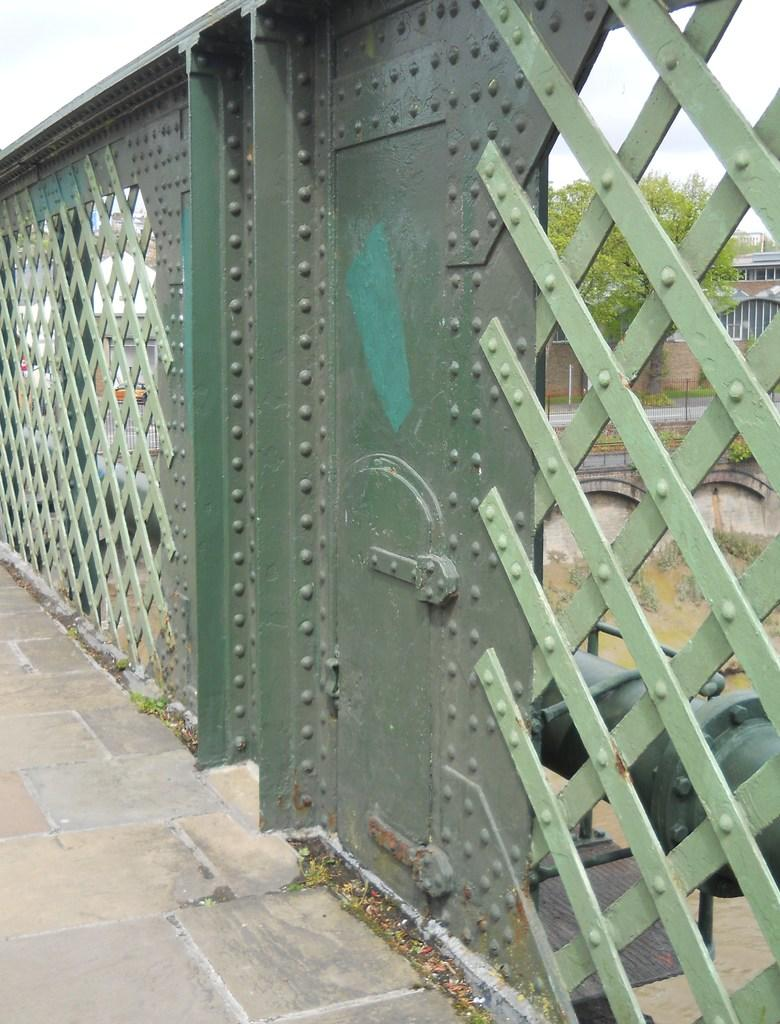What is the main subject in the center of the image? There is a fencing in the center of the image. What type of natural elements can be seen in the image? There are trees in the image. What type of surface is visible at the bottom of the image? There is flooring at the bottom of the image. What route does the ball take to reach the other side of the fencing in the image? There is no ball present in the image, so it is not possible to determine a route. 